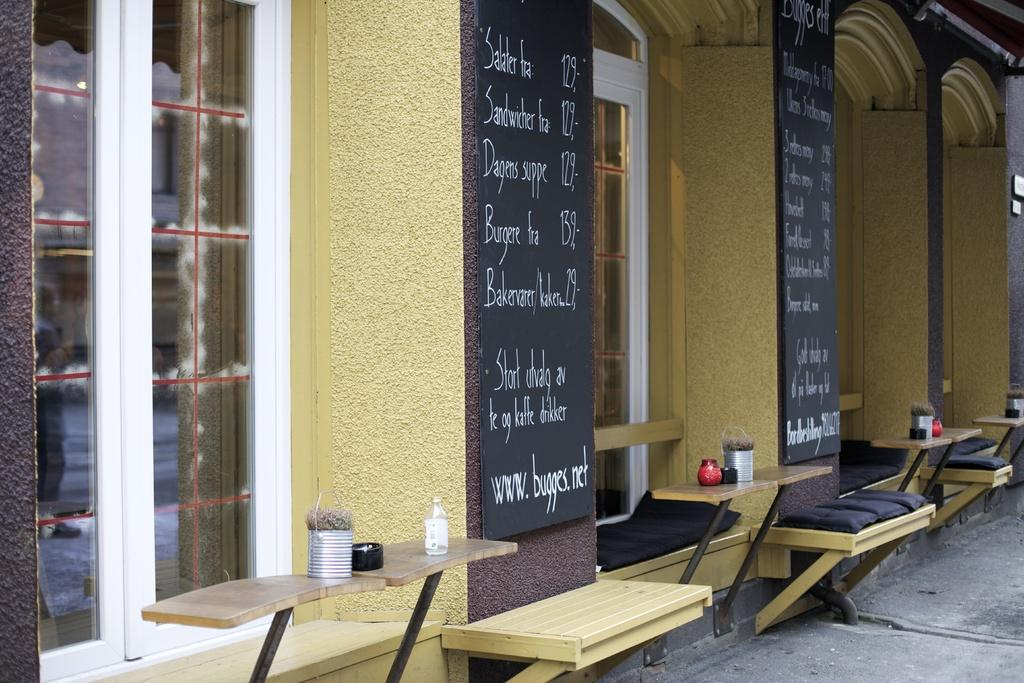What is the main subject of the image? The main subject of the image is a building. What feature can be seen on the building? The building has windows. What type of fuel is being used to power the building in the image? There is no information about the building's power source in the image, so it cannot be determined. 